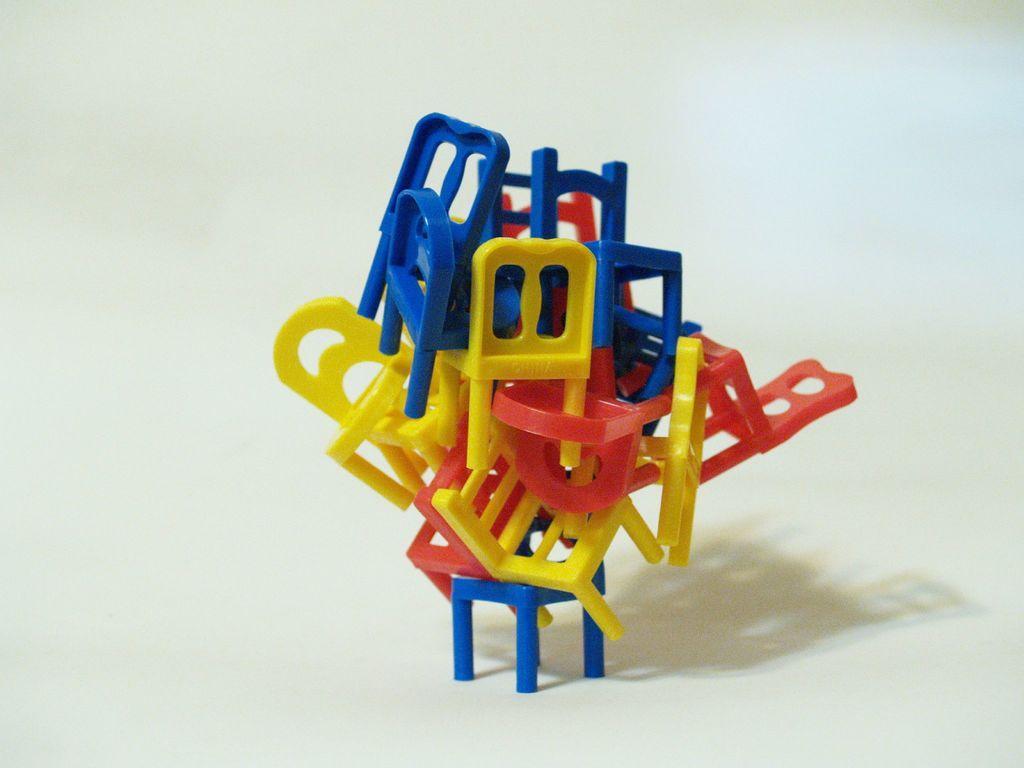Please provide a concise description of this image. In this picture we can see toy chairs, there is a plane background. 